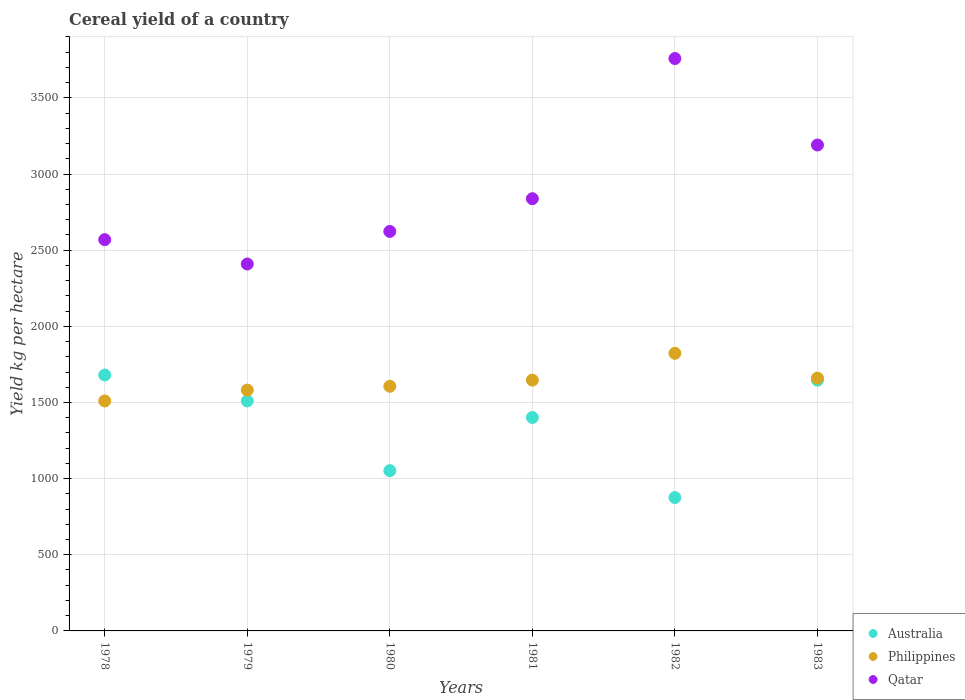How many different coloured dotlines are there?
Offer a terse response. 3. What is the total cereal yield in Australia in 1982?
Give a very brief answer. 875.63. Across all years, what is the maximum total cereal yield in Qatar?
Your answer should be very brief. 3758.24. Across all years, what is the minimum total cereal yield in Australia?
Provide a short and direct response. 875.63. In which year was the total cereal yield in Philippines maximum?
Provide a short and direct response. 1982. In which year was the total cereal yield in Philippines minimum?
Make the answer very short. 1978. What is the total total cereal yield in Australia in the graph?
Your answer should be compact. 8166.03. What is the difference between the total cereal yield in Australia in 1978 and that in 1980?
Give a very brief answer. 627.91. What is the difference between the total cereal yield in Philippines in 1979 and the total cereal yield in Australia in 1978?
Offer a terse response. -98.95. What is the average total cereal yield in Qatar per year?
Offer a very short reply. 2897.94. In the year 1980, what is the difference between the total cereal yield in Australia and total cereal yield in Qatar?
Give a very brief answer. -1570.66. What is the ratio of the total cereal yield in Australia in 1980 to that in 1981?
Provide a short and direct response. 0.75. Is the total cereal yield in Qatar in 1979 less than that in 1981?
Keep it short and to the point. Yes. Is the difference between the total cereal yield in Australia in 1978 and 1982 greater than the difference between the total cereal yield in Qatar in 1978 and 1982?
Give a very brief answer. Yes. What is the difference between the highest and the second highest total cereal yield in Australia?
Offer a terse response. 34. What is the difference between the highest and the lowest total cereal yield in Qatar?
Offer a very short reply. 1349.15. Is the sum of the total cereal yield in Philippines in 1978 and 1980 greater than the maximum total cereal yield in Australia across all years?
Ensure brevity in your answer.  Yes. Is it the case that in every year, the sum of the total cereal yield in Qatar and total cereal yield in Australia  is greater than the total cereal yield in Philippines?
Your response must be concise. Yes. Is the total cereal yield in Australia strictly less than the total cereal yield in Qatar over the years?
Keep it short and to the point. Yes. How many dotlines are there?
Your answer should be very brief. 3. How many years are there in the graph?
Make the answer very short. 6. Are the values on the major ticks of Y-axis written in scientific E-notation?
Provide a succinct answer. No. Does the graph contain grids?
Make the answer very short. Yes. How many legend labels are there?
Ensure brevity in your answer.  3. What is the title of the graph?
Provide a short and direct response. Cereal yield of a country. What is the label or title of the Y-axis?
Your answer should be very brief. Yield kg per hectare. What is the Yield kg per hectare of Australia in 1978?
Make the answer very short. 1680.2. What is the Yield kg per hectare in Philippines in 1978?
Provide a succinct answer. 1509.88. What is the Yield kg per hectare in Qatar in 1978?
Give a very brief answer. 2569.06. What is the Yield kg per hectare in Australia in 1979?
Provide a short and direct response. 1510.16. What is the Yield kg per hectare of Philippines in 1979?
Provide a short and direct response. 1581.26. What is the Yield kg per hectare in Qatar in 1979?
Offer a terse response. 2409.09. What is the Yield kg per hectare of Australia in 1980?
Your answer should be compact. 1052.3. What is the Yield kg per hectare in Philippines in 1980?
Provide a succinct answer. 1606.36. What is the Yield kg per hectare of Qatar in 1980?
Provide a succinct answer. 2622.95. What is the Yield kg per hectare in Australia in 1981?
Offer a terse response. 1401.53. What is the Yield kg per hectare of Philippines in 1981?
Keep it short and to the point. 1646.61. What is the Yield kg per hectare of Qatar in 1981?
Offer a terse response. 2837.84. What is the Yield kg per hectare of Australia in 1982?
Give a very brief answer. 875.63. What is the Yield kg per hectare of Philippines in 1982?
Provide a short and direct response. 1822.65. What is the Yield kg per hectare of Qatar in 1982?
Ensure brevity in your answer.  3758.24. What is the Yield kg per hectare in Australia in 1983?
Give a very brief answer. 1646.21. What is the Yield kg per hectare of Philippines in 1983?
Ensure brevity in your answer.  1659.9. What is the Yield kg per hectare of Qatar in 1983?
Ensure brevity in your answer.  3190.48. Across all years, what is the maximum Yield kg per hectare in Australia?
Offer a very short reply. 1680.2. Across all years, what is the maximum Yield kg per hectare of Philippines?
Keep it short and to the point. 1822.65. Across all years, what is the maximum Yield kg per hectare of Qatar?
Make the answer very short. 3758.24. Across all years, what is the minimum Yield kg per hectare in Australia?
Keep it short and to the point. 875.63. Across all years, what is the minimum Yield kg per hectare of Philippines?
Provide a succinct answer. 1509.88. Across all years, what is the minimum Yield kg per hectare in Qatar?
Your response must be concise. 2409.09. What is the total Yield kg per hectare of Australia in the graph?
Make the answer very short. 8166.03. What is the total Yield kg per hectare in Philippines in the graph?
Keep it short and to the point. 9826.66. What is the total Yield kg per hectare of Qatar in the graph?
Provide a short and direct response. 1.74e+04. What is the difference between the Yield kg per hectare of Australia in 1978 and that in 1979?
Your answer should be very brief. 170.04. What is the difference between the Yield kg per hectare in Philippines in 1978 and that in 1979?
Give a very brief answer. -71.37. What is the difference between the Yield kg per hectare of Qatar in 1978 and that in 1979?
Offer a terse response. 159.97. What is the difference between the Yield kg per hectare in Australia in 1978 and that in 1980?
Ensure brevity in your answer.  627.91. What is the difference between the Yield kg per hectare of Philippines in 1978 and that in 1980?
Make the answer very short. -96.47. What is the difference between the Yield kg per hectare in Qatar in 1978 and that in 1980?
Your answer should be compact. -53.89. What is the difference between the Yield kg per hectare of Australia in 1978 and that in 1981?
Provide a short and direct response. 278.67. What is the difference between the Yield kg per hectare of Philippines in 1978 and that in 1981?
Your answer should be very brief. -136.72. What is the difference between the Yield kg per hectare of Qatar in 1978 and that in 1981?
Provide a short and direct response. -268.78. What is the difference between the Yield kg per hectare of Australia in 1978 and that in 1982?
Offer a very short reply. 804.58. What is the difference between the Yield kg per hectare of Philippines in 1978 and that in 1982?
Your answer should be very brief. -312.76. What is the difference between the Yield kg per hectare of Qatar in 1978 and that in 1982?
Your answer should be compact. -1189.18. What is the difference between the Yield kg per hectare of Australia in 1978 and that in 1983?
Your response must be concise. 34. What is the difference between the Yield kg per hectare of Philippines in 1978 and that in 1983?
Give a very brief answer. -150.02. What is the difference between the Yield kg per hectare in Qatar in 1978 and that in 1983?
Provide a succinct answer. -621.41. What is the difference between the Yield kg per hectare of Australia in 1979 and that in 1980?
Offer a terse response. 457.87. What is the difference between the Yield kg per hectare of Philippines in 1979 and that in 1980?
Ensure brevity in your answer.  -25.1. What is the difference between the Yield kg per hectare in Qatar in 1979 and that in 1980?
Your answer should be very brief. -213.86. What is the difference between the Yield kg per hectare of Australia in 1979 and that in 1981?
Provide a succinct answer. 108.63. What is the difference between the Yield kg per hectare of Philippines in 1979 and that in 1981?
Provide a succinct answer. -65.35. What is the difference between the Yield kg per hectare of Qatar in 1979 and that in 1981?
Offer a very short reply. -428.75. What is the difference between the Yield kg per hectare of Australia in 1979 and that in 1982?
Give a very brief answer. 634.54. What is the difference between the Yield kg per hectare of Philippines in 1979 and that in 1982?
Provide a short and direct response. -241.39. What is the difference between the Yield kg per hectare in Qatar in 1979 and that in 1982?
Make the answer very short. -1349.15. What is the difference between the Yield kg per hectare of Australia in 1979 and that in 1983?
Your answer should be compact. -136.04. What is the difference between the Yield kg per hectare in Philippines in 1979 and that in 1983?
Ensure brevity in your answer.  -78.65. What is the difference between the Yield kg per hectare of Qatar in 1979 and that in 1983?
Provide a short and direct response. -781.38. What is the difference between the Yield kg per hectare in Australia in 1980 and that in 1981?
Keep it short and to the point. -349.24. What is the difference between the Yield kg per hectare in Philippines in 1980 and that in 1981?
Give a very brief answer. -40.25. What is the difference between the Yield kg per hectare in Qatar in 1980 and that in 1981?
Offer a very short reply. -214.89. What is the difference between the Yield kg per hectare of Australia in 1980 and that in 1982?
Your answer should be compact. 176.67. What is the difference between the Yield kg per hectare in Philippines in 1980 and that in 1982?
Give a very brief answer. -216.29. What is the difference between the Yield kg per hectare of Qatar in 1980 and that in 1982?
Offer a very short reply. -1135.29. What is the difference between the Yield kg per hectare in Australia in 1980 and that in 1983?
Your answer should be compact. -593.91. What is the difference between the Yield kg per hectare in Philippines in 1980 and that in 1983?
Provide a short and direct response. -53.55. What is the difference between the Yield kg per hectare of Qatar in 1980 and that in 1983?
Your response must be concise. -567.52. What is the difference between the Yield kg per hectare of Australia in 1981 and that in 1982?
Provide a short and direct response. 525.91. What is the difference between the Yield kg per hectare in Philippines in 1981 and that in 1982?
Your response must be concise. -176.04. What is the difference between the Yield kg per hectare in Qatar in 1981 and that in 1982?
Provide a short and direct response. -920.4. What is the difference between the Yield kg per hectare of Australia in 1981 and that in 1983?
Your answer should be compact. -244.67. What is the difference between the Yield kg per hectare in Philippines in 1981 and that in 1983?
Provide a short and direct response. -13.3. What is the difference between the Yield kg per hectare of Qatar in 1981 and that in 1983?
Provide a short and direct response. -352.64. What is the difference between the Yield kg per hectare in Australia in 1982 and that in 1983?
Your answer should be very brief. -770.58. What is the difference between the Yield kg per hectare in Philippines in 1982 and that in 1983?
Provide a short and direct response. 162.74. What is the difference between the Yield kg per hectare of Qatar in 1982 and that in 1983?
Keep it short and to the point. 567.77. What is the difference between the Yield kg per hectare in Australia in 1978 and the Yield kg per hectare in Philippines in 1979?
Your answer should be compact. 98.95. What is the difference between the Yield kg per hectare in Australia in 1978 and the Yield kg per hectare in Qatar in 1979?
Ensure brevity in your answer.  -728.89. What is the difference between the Yield kg per hectare in Philippines in 1978 and the Yield kg per hectare in Qatar in 1979?
Keep it short and to the point. -899.21. What is the difference between the Yield kg per hectare of Australia in 1978 and the Yield kg per hectare of Philippines in 1980?
Ensure brevity in your answer.  73.84. What is the difference between the Yield kg per hectare of Australia in 1978 and the Yield kg per hectare of Qatar in 1980?
Your answer should be very brief. -942.75. What is the difference between the Yield kg per hectare in Philippines in 1978 and the Yield kg per hectare in Qatar in 1980?
Make the answer very short. -1113.07. What is the difference between the Yield kg per hectare in Australia in 1978 and the Yield kg per hectare in Philippines in 1981?
Offer a terse response. 33.6. What is the difference between the Yield kg per hectare in Australia in 1978 and the Yield kg per hectare in Qatar in 1981?
Give a very brief answer. -1157.63. What is the difference between the Yield kg per hectare of Philippines in 1978 and the Yield kg per hectare of Qatar in 1981?
Provide a succinct answer. -1327.95. What is the difference between the Yield kg per hectare of Australia in 1978 and the Yield kg per hectare of Philippines in 1982?
Keep it short and to the point. -142.44. What is the difference between the Yield kg per hectare of Australia in 1978 and the Yield kg per hectare of Qatar in 1982?
Your answer should be very brief. -2078.04. What is the difference between the Yield kg per hectare in Philippines in 1978 and the Yield kg per hectare in Qatar in 1982?
Your answer should be very brief. -2248.36. What is the difference between the Yield kg per hectare in Australia in 1978 and the Yield kg per hectare in Philippines in 1983?
Provide a succinct answer. 20.3. What is the difference between the Yield kg per hectare in Australia in 1978 and the Yield kg per hectare in Qatar in 1983?
Make the answer very short. -1510.27. What is the difference between the Yield kg per hectare in Philippines in 1978 and the Yield kg per hectare in Qatar in 1983?
Make the answer very short. -1680.59. What is the difference between the Yield kg per hectare of Australia in 1979 and the Yield kg per hectare of Philippines in 1980?
Offer a very short reply. -96.2. What is the difference between the Yield kg per hectare in Australia in 1979 and the Yield kg per hectare in Qatar in 1980?
Offer a terse response. -1112.79. What is the difference between the Yield kg per hectare in Philippines in 1979 and the Yield kg per hectare in Qatar in 1980?
Your answer should be compact. -1041.69. What is the difference between the Yield kg per hectare of Australia in 1979 and the Yield kg per hectare of Philippines in 1981?
Your response must be concise. -136.44. What is the difference between the Yield kg per hectare in Australia in 1979 and the Yield kg per hectare in Qatar in 1981?
Your answer should be compact. -1327.67. What is the difference between the Yield kg per hectare in Philippines in 1979 and the Yield kg per hectare in Qatar in 1981?
Your answer should be compact. -1256.58. What is the difference between the Yield kg per hectare in Australia in 1979 and the Yield kg per hectare in Philippines in 1982?
Provide a short and direct response. -312.48. What is the difference between the Yield kg per hectare in Australia in 1979 and the Yield kg per hectare in Qatar in 1982?
Ensure brevity in your answer.  -2248.08. What is the difference between the Yield kg per hectare in Philippines in 1979 and the Yield kg per hectare in Qatar in 1982?
Offer a very short reply. -2176.99. What is the difference between the Yield kg per hectare in Australia in 1979 and the Yield kg per hectare in Philippines in 1983?
Keep it short and to the point. -149.74. What is the difference between the Yield kg per hectare in Australia in 1979 and the Yield kg per hectare in Qatar in 1983?
Provide a short and direct response. -1680.31. What is the difference between the Yield kg per hectare of Philippines in 1979 and the Yield kg per hectare of Qatar in 1983?
Your answer should be very brief. -1609.22. What is the difference between the Yield kg per hectare in Australia in 1980 and the Yield kg per hectare in Philippines in 1981?
Ensure brevity in your answer.  -594.31. What is the difference between the Yield kg per hectare of Australia in 1980 and the Yield kg per hectare of Qatar in 1981?
Your response must be concise. -1785.54. What is the difference between the Yield kg per hectare of Philippines in 1980 and the Yield kg per hectare of Qatar in 1981?
Offer a terse response. -1231.48. What is the difference between the Yield kg per hectare of Australia in 1980 and the Yield kg per hectare of Philippines in 1982?
Ensure brevity in your answer.  -770.35. What is the difference between the Yield kg per hectare of Australia in 1980 and the Yield kg per hectare of Qatar in 1982?
Provide a short and direct response. -2705.95. What is the difference between the Yield kg per hectare of Philippines in 1980 and the Yield kg per hectare of Qatar in 1982?
Your answer should be compact. -2151.88. What is the difference between the Yield kg per hectare in Australia in 1980 and the Yield kg per hectare in Philippines in 1983?
Give a very brief answer. -607.61. What is the difference between the Yield kg per hectare in Australia in 1980 and the Yield kg per hectare in Qatar in 1983?
Your response must be concise. -2138.18. What is the difference between the Yield kg per hectare in Philippines in 1980 and the Yield kg per hectare in Qatar in 1983?
Your answer should be very brief. -1584.12. What is the difference between the Yield kg per hectare of Australia in 1981 and the Yield kg per hectare of Philippines in 1982?
Provide a succinct answer. -421.11. What is the difference between the Yield kg per hectare of Australia in 1981 and the Yield kg per hectare of Qatar in 1982?
Give a very brief answer. -2356.71. What is the difference between the Yield kg per hectare in Philippines in 1981 and the Yield kg per hectare in Qatar in 1982?
Provide a short and direct response. -2111.64. What is the difference between the Yield kg per hectare of Australia in 1981 and the Yield kg per hectare of Philippines in 1983?
Your answer should be very brief. -258.37. What is the difference between the Yield kg per hectare in Australia in 1981 and the Yield kg per hectare in Qatar in 1983?
Your answer should be very brief. -1788.94. What is the difference between the Yield kg per hectare in Philippines in 1981 and the Yield kg per hectare in Qatar in 1983?
Keep it short and to the point. -1543.87. What is the difference between the Yield kg per hectare in Australia in 1982 and the Yield kg per hectare in Philippines in 1983?
Keep it short and to the point. -784.28. What is the difference between the Yield kg per hectare of Australia in 1982 and the Yield kg per hectare of Qatar in 1983?
Give a very brief answer. -2314.85. What is the difference between the Yield kg per hectare in Philippines in 1982 and the Yield kg per hectare in Qatar in 1983?
Offer a very short reply. -1367.83. What is the average Yield kg per hectare in Australia per year?
Keep it short and to the point. 1361.01. What is the average Yield kg per hectare of Philippines per year?
Give a very brief answer. 1637.78. What is the average Yield kg per hectare of Qatar per year?
Offer a terse response. 2897.94. In the year 1978, what is the difference between the Yield kg per hectare in Australia and Yield kg per hectare in Philippines?
Your response must be concise. 170.32. In the year 1978, what is the difference between the Yield kg per hectare in Australia and Yield kg per hectare in Qatar?
Make the answer very short. -888.86. In the year 1978, what is the difference between the Yield kg per hectare of Philippines and Yield kg per hectare of Qatar?
Provide a succinct answer. -1059.18. In the year 1979, what is the difference between the Yield kg per hectare of Australia and Yield kg per hectare of Philippines?
Ensure brevity in your answer.  -71.09. In the year 1979, what is the difference between the Yield kg per hectare of Australia and Yield kg per hectare of Qatar?
Offer a very short reply. -898.93. In the year 1979, what is the difference between the Yield kg per hectare of Philippines and Yield kg per hectare of Qatar?
Offer a very short reply. -827.83. In the year 1980, what is the difference between the Yield kg per hectare of Australia and Yield kg per hectare of Philippines?
Offer a very short reply. -554.07. In the year 1980, what is the difference between the Yield kg per hectare in Australia and Yield kg per hectare in Qatar?
Offer a very short reply. -1570.66. In the year 1980, what is the difference between the Yield kg per hectare of Philippines and Yield kg per hectare of Qatar?
Keep it short and to the point. -1016.59. In the year 1981, what is the difference between the Yield kg per hectare of Australia and Yield kg per hectare of Philippines?
Make the answer very short. -245.07. In the year 1981, what is the difference between the Yield kg per hectare of Australia and Yield kg per hectare of Qatar?
Your answer should be compact. -1436.3. In the year 1981, what is the difference between the Yield kg per hectare in Philippines and Yield kg per hectare in Qatar?
Ensure brevity in your answer.  -1191.23. In the year 1982, what is the difference between the Yield kg per hectare in Australia and Yield kg per hectare in Philippines?
Your answer should be very brief. -947.02. In the year 1982, what is the difference between the Yield kg per hectare in Australia and Yield kg per hectare in Qatar?
Keep it short and to the point. -2882.61. In the year 1982, what is the difference between the Yield kg per hectare in Philippines and Yield kg per hectare in Qatar?
Your answer should be compact. -1935.59. In the year 1983, what is the difference between the Yield kg per hectare in Australia and Yield kg per hectare in Philippines?
Offer a very short reply. -13.7. In the year 1983, what is the difference between the Yield kg per hectare of Australia and Yield kg per hectare of Qatar?
Offer a terse response. -1544.27. In the year 1983, what is the difference between the Yield kg per hectare of Philippines and Yield kg per hectare of Qatar?
Offer a terse response. -1530.57. What is the ratio of the Yield kg per hectare in Australia in 1978 to that in 1979?
Offer a terse response. 1.11. What is the ratio of the Yield kg per hectare of Philippines in 1978 to that in 1979?
Offer a terse response. 0.95. What is the ratio of the Yield kg per hectare in Qatar in 1978 to that in 1979?
Offer a very short reply. 1.07. What is the ratio of the Yield kg per hectare in Australia in 1978 to that in 1980?
Give a very brief answer. 1.6. What is the ratio of the Yield kg per hectare in Philippines in 1978 to that in 1980?
Provide a succinct answer. 0.94. What is the ratio of the Yield kg per hectare in Qatar in 1978 to that in 1980?
Ensure brevity in your answer.  0.98. What is the ratio of the Yield kg per hectare in Australia in 1978 to that in 1981?
Your response must be concise. 1.2. What is the ratio of the Yield kg per hectare of Philippines in 1978 to that in 1981?
Your response must be concise. 0.92. What is the ratio of the Yield kg per hectare in Qatar in 1978 to that in 1981?
Provide a succinct answer. 0.91. What is the ratio of the Yield kg per hectare in Australia in 1978 to that in 1982?
Provide a succinct answer. 1.92. What is the ratio of the Yield kg per hectare in Philippines in 1978 to that in 1982?
Provide a short and direct response. 0.83. What is the ratio of the Yield kg per hectare of Qatar in 1978 to that in 1982?
Provide a succinct answer. 0.68. What is the ratio of the Yield kg per hectare of Australia in 1978 to that in 1983?
Ensure brevity in your answer.  1.02. What is the ratio of the Yield kg per hectare of Philippines in 1978 to that in 1983?
Provide a succinct answer. 0.91. What is the ratio of the Yield kg per hectare in Qatar in 1978 to that in 1983?
Provide a succinct answer. 0.81. What is the ratio of the Yield kg per hectare of Australia in 1979 to that in 1980?
Provide a short and direct response. 1.44. What is the ratio of the Yield kg per hectare of Philippines in 1979 to that in 1980?
Make the answer very short. 0.98. What is the ratio of the Yield kg per hectare in Qatar in 1979 to that in 1980?
Offer a terse response. 0.92. What is the ratio of the Yield kg per hectare in Australia in 1979 to that in 1981?
Keep it short and to the point. 1.08. What is the ratio of the Yield kg per hectare of Philippines in 1979 to that in 1981?
Offer a very short reply. 0.96. What is the ratio of the Yield kg per hectare of Qatar in 1979 to that in 1981?
Your response must be concise. 0.85. What is the ratio of the Yield kg per hectare in Australia in 1979 to that in 1982?
Offer a terse response. 1.72. What is the ratio of the Yield kg per hectare of Philippines in 1979 to that in 1982?
Ensure brevity in your answer.  0.87. What is the ratio of the Yield kg per hectare of Qatar in 1979 to that in 1982?
Your response must be concise. 0.64. What is the ratio of the Yield kg per hectare of Australia in 1979 to that in 1983?
Offer a very short reply. 0.92. What is the ratio of the Yield kg per hectare in Philippines in 1979 to that in 1983?
Your answer should be compact. 0.95. What is the ratio of the Yield kg per hectare in Qatar in 1979 to that in 1983?
Offer a very short reply. 0.76. What is the ratio of the Yield kg per hectare in Australia in 1980 to that in 1981?
Keep it short and to the point. 0.75. What is the ratio of the Yield kg per hectare in Philippines in 1980 to that in 1981?
Make the answer very short. 0.98. What is the ratio of the Yield kg per hectare in Qatar in 1980 to that in 1981?
Give a very brief answer. 0.92. What is the ratio of the Yield kg per hectare in Australia in 1980 to that in 1982?
Give a very brief answer. 1.2. What is the ratio of the Yield kg per hectare of Philippines in 1980 to that in 1982?
Make the answer very short. 0.88. What is the ratio of the Yield kg per hectare of Qatar in 1980 to that in 1982?
Give a very brief answer. 0.7. What is the ratio of the Yield kg per hectare of Australia in 1980 to that in 1983?
Ensure brevity in your answer.  0.64. What is the ratio of the Yield kg per hectare in Qatar in 1980 to that in 1983?
Offer a very short reply. 0.82. What is the ratio of the Yield kg per hectare of Australia in 1981 to that in 1982?
Your answer should be very brief. 1.6. What is the ratio of the Yield kg per hectare in Philippines in 1981 to that in 1982?
Your answer should be very brief. 0.9. What is the ratio of the Yield kg per hectare of Qatar in 1981 to that in 1982?
Ensure brevity in your answer.  0.76. What is the ratio of the Yield kg per hectare in Australia in 1981 to that in 1983?
Your answer should be very brief. 0.85. What is the ratio of the Yield kg per hectare of Qatar in 1981 to that in 1983?
Your response must be concise. 0.89. What is the ratio of the Yield kg per hectare of Australia in 1982 to that in 1983?
Your answer should be very brief. 0.53. What is the ratio of the Yield kg per hectare in Philippines in 1982 to that in 1983?
Make the answer very short. 1.1. What is the ratio of the Yield kg per hectare in Qatar in 1982 to that in 1983?
Keep it short and to the point. 1.18. What is the difference between the highest and the second highest Yield kg per hectare in Australia?
Make the answer very short. 34. What is the difference between the highest and the second highest Yield kg per hectare in Philippines?
Ensure brevity in your answer.  162.74. What is the difference between the highest and the second highest Yield kg per hectare of Qatar?
Make the answer very short. 567.77. What is the difference between the highest and the lowest Yield kg per hectare of Australia?
Your response must be concise. 804.58. What is the difference between the highest and the lowest Yield kg per hectare of Philippines?
Provide a succinct answer. 312.76. What is the difference between the highest and the lowest Yield kg per hectare in Qatar?
Ensure brevity in your answer.  1349.15. 